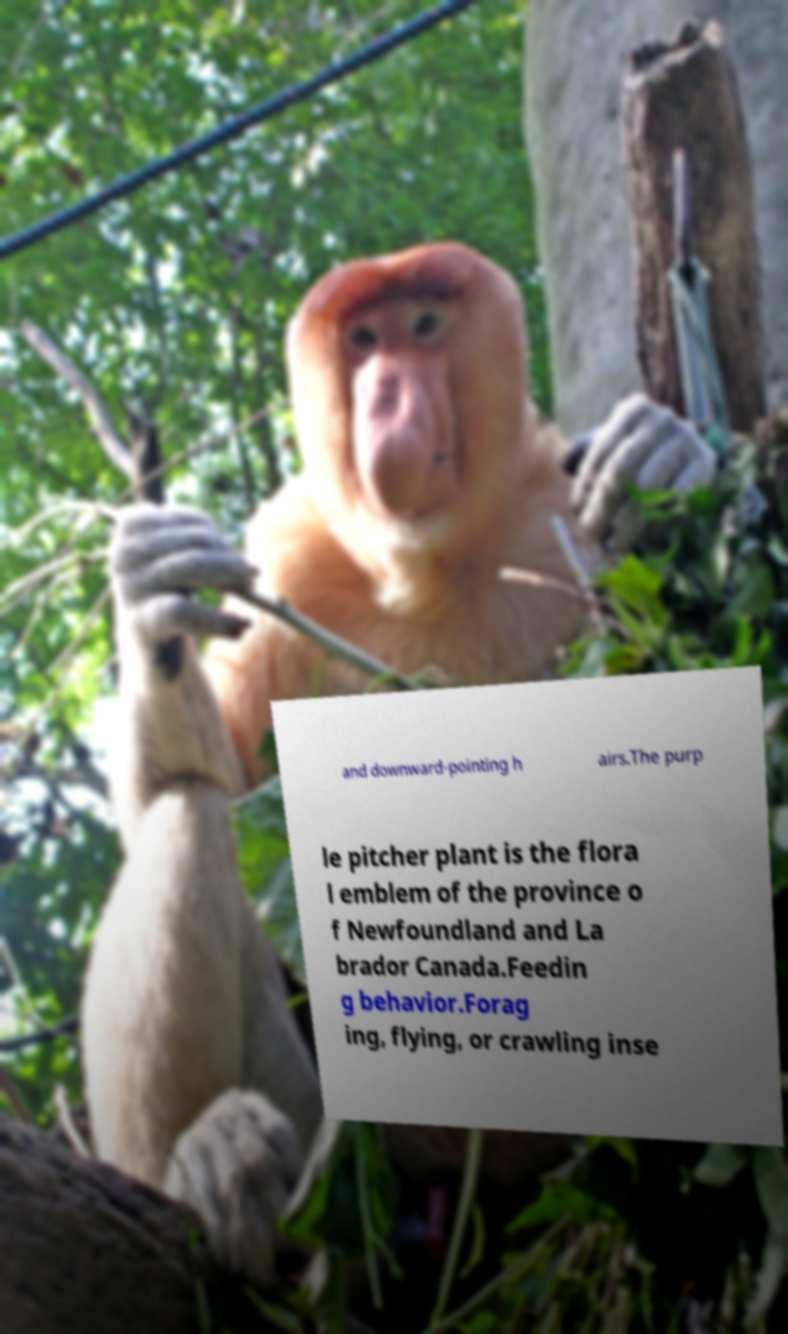For documentation purposes, I need the text within this image transcribed. Could you provide that? and downward-pointing h airs.The purp le pitcher plant is the flora l emblem of the province o f Newfoundland and La brador Canada.Feedin g behavior.Forag ing, flying, or crawling inse 